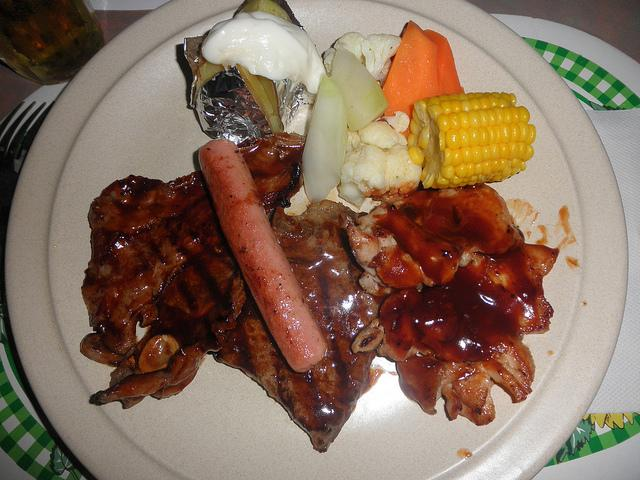Which dairy product is most prominent here? Please explain your reasoning. sour cream. A white dollop with potatoes is often sour cream. 